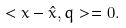<formula> <loc_0><loc_0><loc_500><loc_500>< x - \hat { x } , q > = 0 .</formula> 